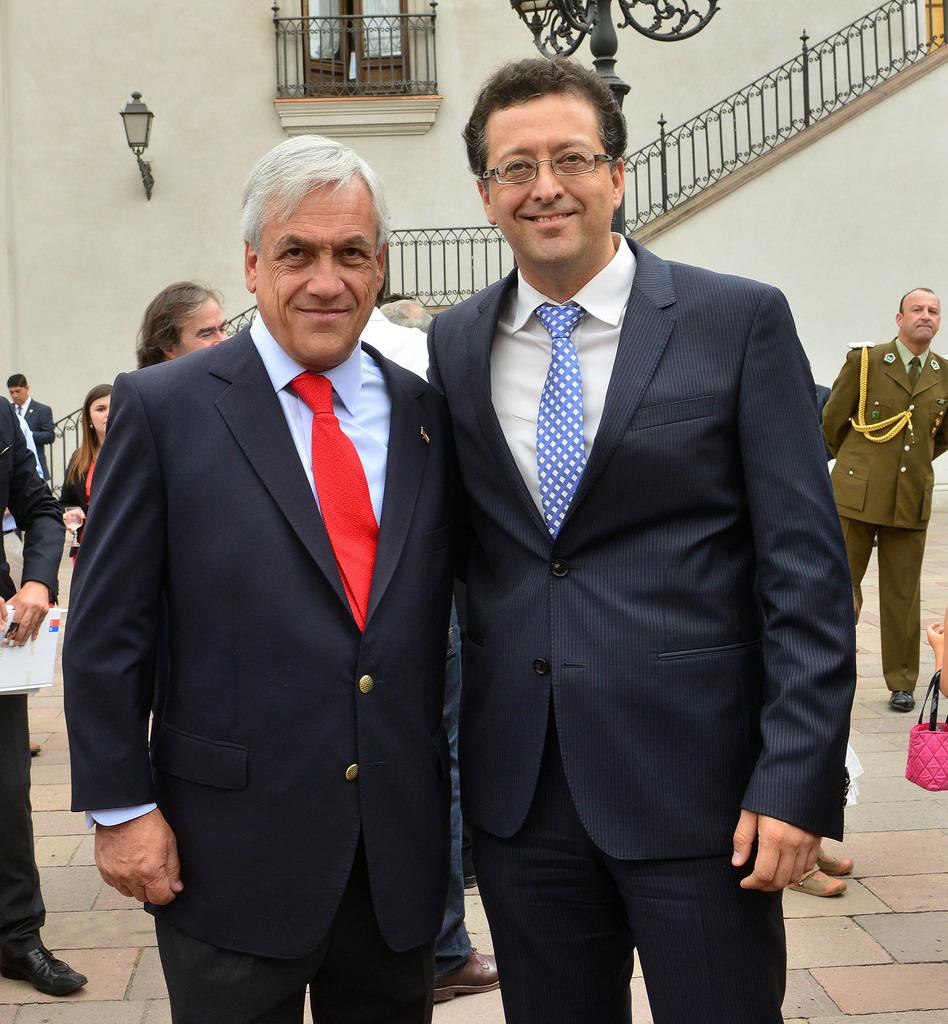How many people are smiling in the image? There are two persons standing and smiling in the image. What can be seen in the background of the image? There is a group of people standing in the background of the image, as well as iron rods and a window of a building. Can you describe the lighting in the image? Yes, there is light is visible in the image. How steep is the slope in the image? There is no slope present in the image. How quiet is the environment in the image? The image does not provide any information about the noise level or quietness of the environment. 